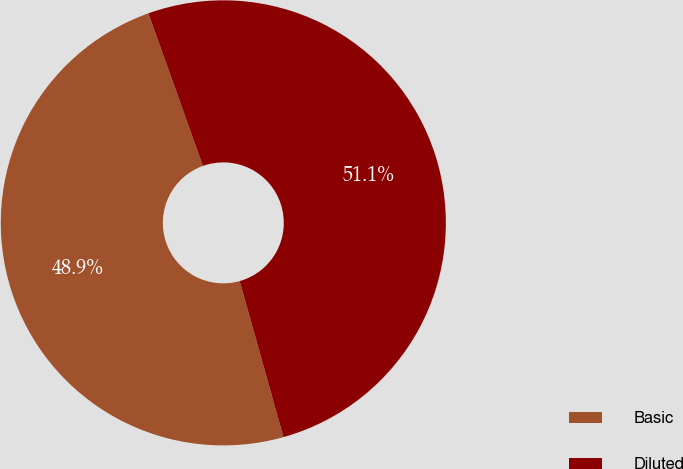Convert chart. <chart><loc_0><loc_0><loc_500><loc_500><pie_chart><fcel>Basic<fcel>Diluted<nl><fcel>48.89%<fcel>51.11%<nl></chart> 